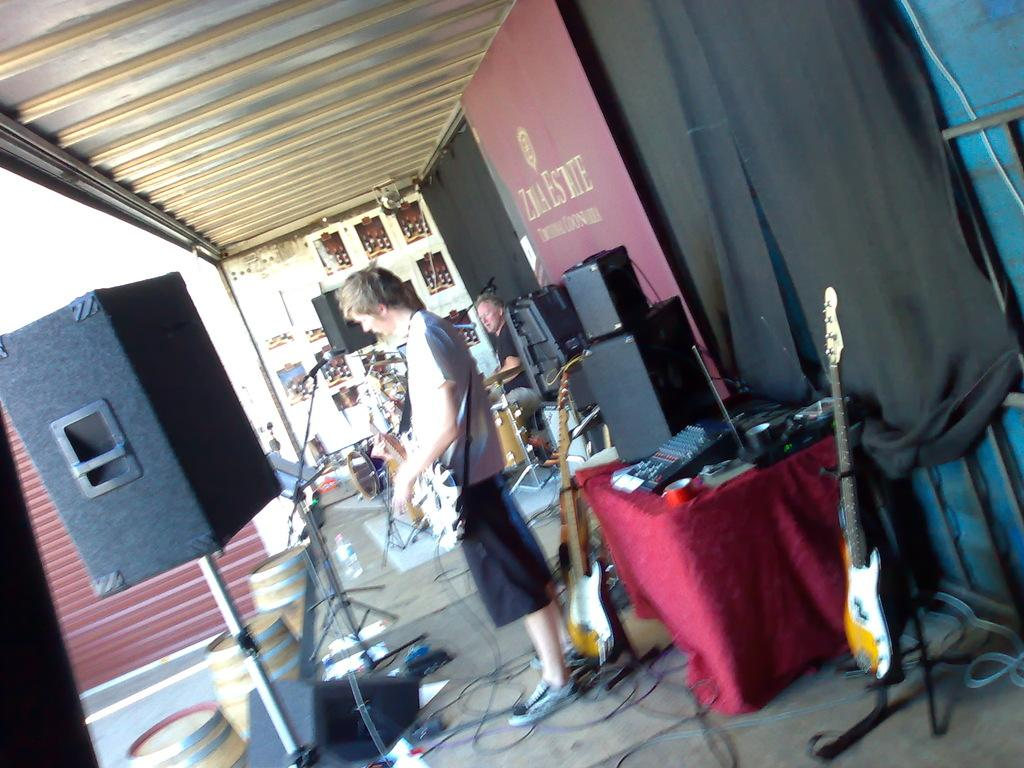What is the person in the image holding? The person in the image is holding a guitar. How many guitars can be seen in the image? There are guitars in the image, but the exact number is not specified. What other items related to music can be seen in the image? There are speakers, musical instruments, and a microphone in the image. What is on the dais in the image? There are barrels on the dais in the image. What can be seen in the background of the image? There is a curtain, a speaker, and a wall in the background of the image. What type of pest can be seen crawling on the guitar in the image? There are no pests visible in the image, and no pests are mentioned in the provided facts. How many drumsticks are visible in the image? There is no mention of drumsticks or drums in the provided facts, so we cannot determine if any are visible in the image. 